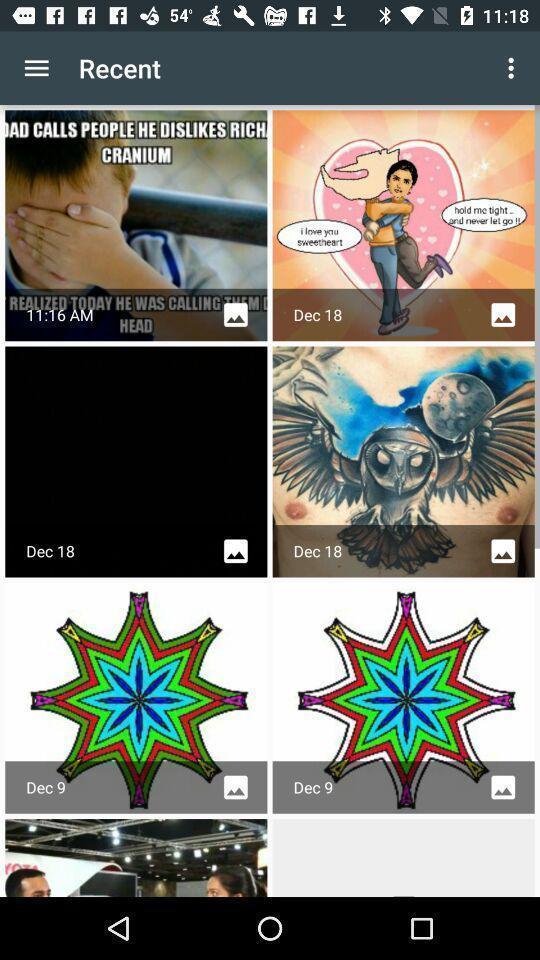Summarize the information in this screenshot. Screen shows recent images in gallery app. 